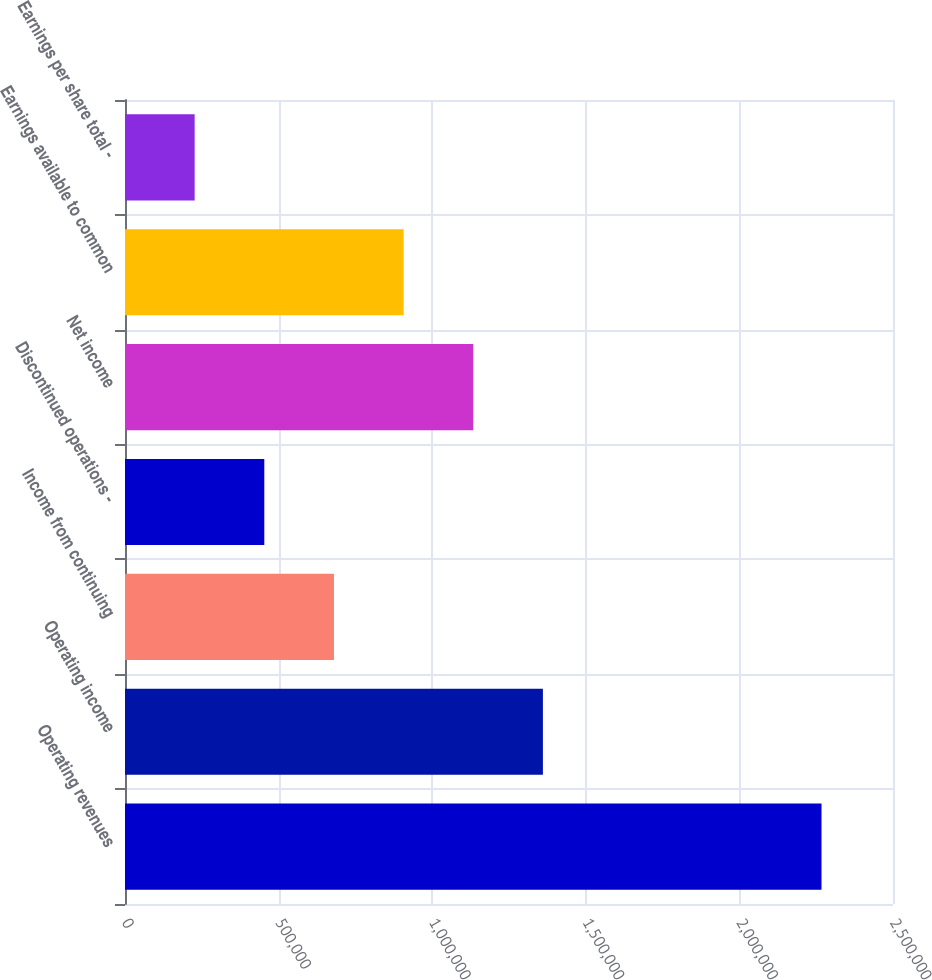<chart> <loc_0><loc_0><loc_500><loc_500><bar_chart><fcel>Operating revenues<fcel>Operating income<fcel>Income from continuing<fcel>Discontinued operations -<fcel>Net income<fcel>Earnings available to common<fcel>Earnings per share total -<nl><fcel>2.26729e+06<fcel>1.36038e+06<fcel>680188<fcel>453459<fcel>1.13365e+06<fcel>906917<fcel>226729<nl></chart> 